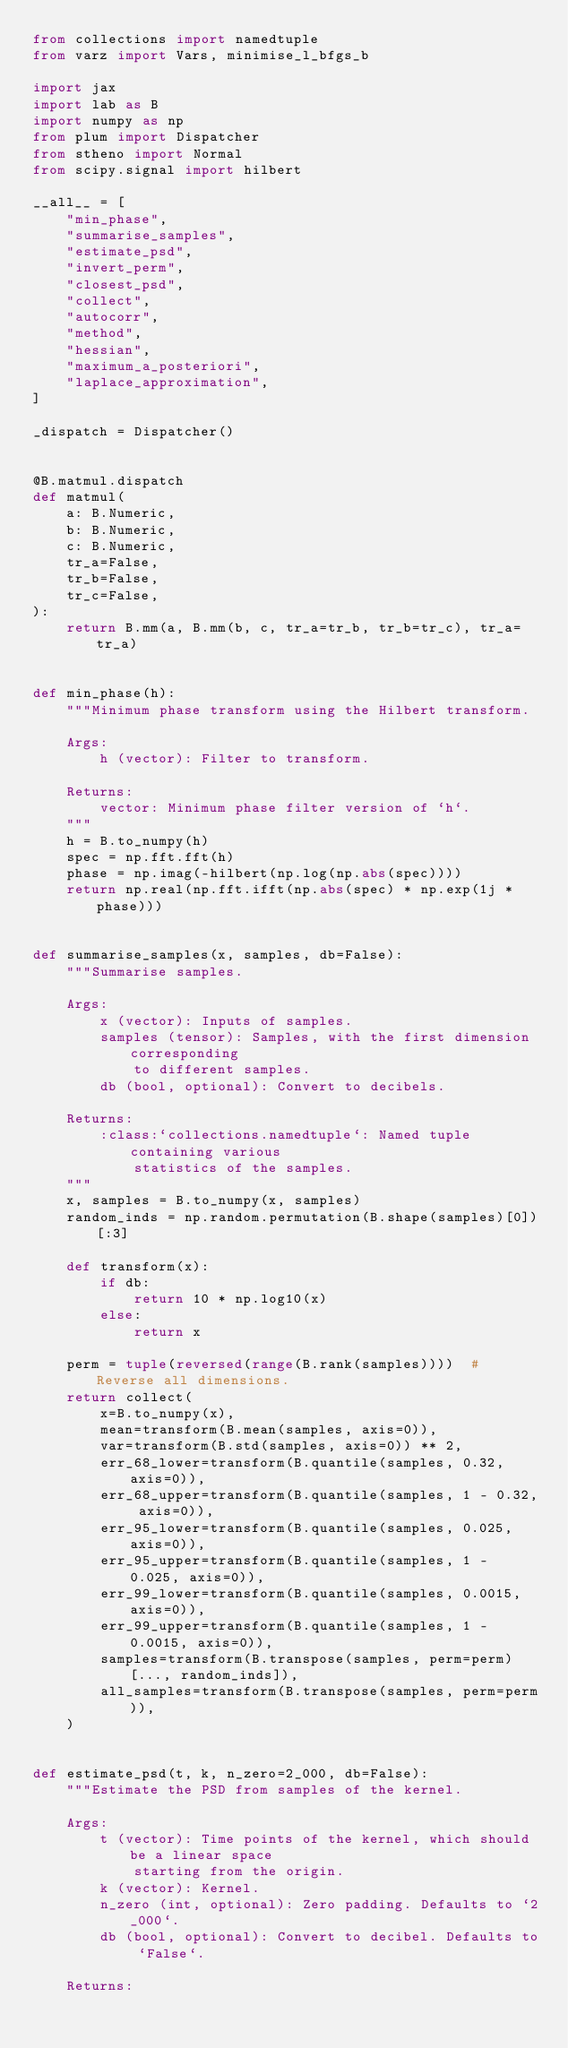Convert code to text. <code><loc_0><loc_0><loc_500><loc_500><_Python_>from collections import namedtuple
from varz import Vars, minimise_l_bfgs_b

import jax
import lab as B
import numpy as np
from plum import Dispatcher
from stheno import Normal
from scipy.signal import hilbert

__all__ = [
    "min_phase",
    "summarise_samples",
    "estimate_psd",
    "invert_perm",
    "closest_psd",
    "collect",
    "autocorr",
    "method",
    "hessian",
    "maximum_a_posteriori",
    "laplace_approximation",
]

_dispatch = Dispatcher()


@B.matmul.dispatch
def matmul(
    a: B.Numeric,
    b: B.Numeric,
    c: B.Numeric,
    tr_a=False,
    tr_b=False,
    tr_c=False,
):
    return B.mm(a, B.mm(b, c, tr_a=tr_b, tr_b=tr_c), tr_a=tr_a)


def min_phase(h):
    """Minimum phase transform using the Hilbert transform.

    Args:
        h (vector): Filter to transform.

    Returns:
        vector: Minimum phase filter version of `h`.
    """
    h = B.to_numpy(h)
    spec = np.fft.fft(h)
    phase = np.imag(-hilbert(np.log(np.abs(spec))))
    return np.real(np.fft.ifft(np.abs(spec) * np.exp(1j * phase)))


def summarise_samples(x, samples, db=False):
    """Summarise samples.

    Args:
        x (vector): Inputs of samples.
        samples (tensor): Samples, with the first dimension corresponding
            to different samples.
        db (bool, optional): Convert to decibels.

    Returns:
        :class:`collections.namedtuple`: Named tuple containing various
            statistics of the samples.
    """
    x, samples = B.to_numpy(x, samples)
    random_inds = np.random.permutation(B.shape(samples)[0])[:3]

    def transform(x):
        if db:
            return 10 * np.log10(x)
        else:
            return x

    perm = tuple(reversed(range(B.rank(samples))))  # Reverse all dimensions.
    return collect(
        x=B.to_numpy(x),
        mean=transform(B.mean(samples, axis=0)),
        var=transform(B.std(samples, axis=0)) ** 2,
        err_68_lower=transform(B.quantile(samples, 0.32, axis=0)),
        err_68_upper=transform(B.quantile(samples, 1 - 0.32, axis=0)),
        err_95_lower=transform(B.quantile(samples, 0.025, axis=0)),
        err_95_upper=transform(B.quantile(samples, 1 - 0.025, axis=0)),
        err_99_lower=transform(B.quantile(samples, 0.0015, axis=0)),
        err_99_upper=transform(B.quantile(samples, 1 - 0.0015, axis=0)),
        samples=transform(B.transpose(samples, perm=perm)[..., random_inds]),
        all_samples=transform(B.transpose(samples, perm=perm)),
    )


def estimate_psd(t, k, n_zero=2_000, db=False):
    """Estimate the PSD from samples of the kernel.

    Args:
        t (vector): Time points of the kernel, which should be a linear space
            starting from the origin.
        k (vector): Kernel.
        n_zero (int, optional): Zero padding. Defaults to `2_000`.
        db (bool, optional): Convert to decibel. Defaults to `False`.

    Returns:</code> 